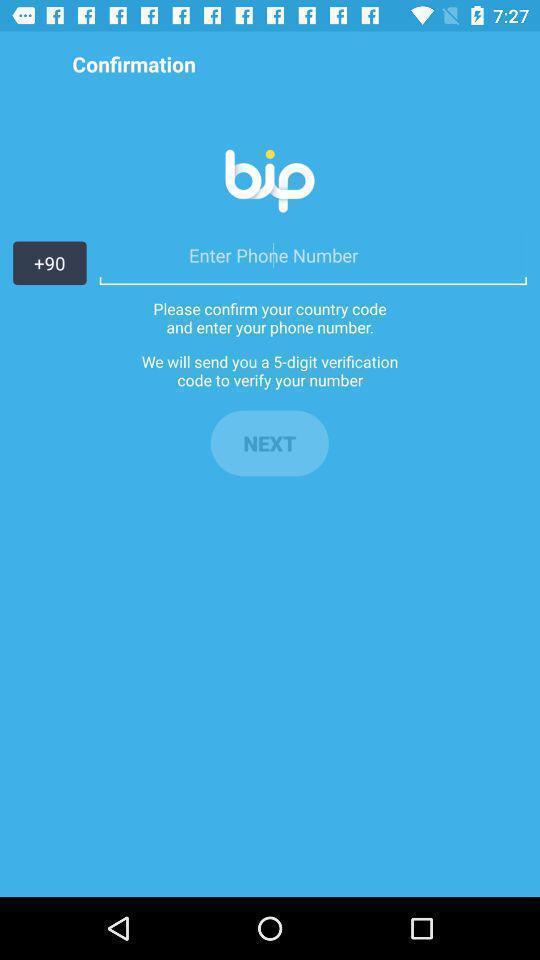Tell me what you see in this picture. Page showing information of number. 